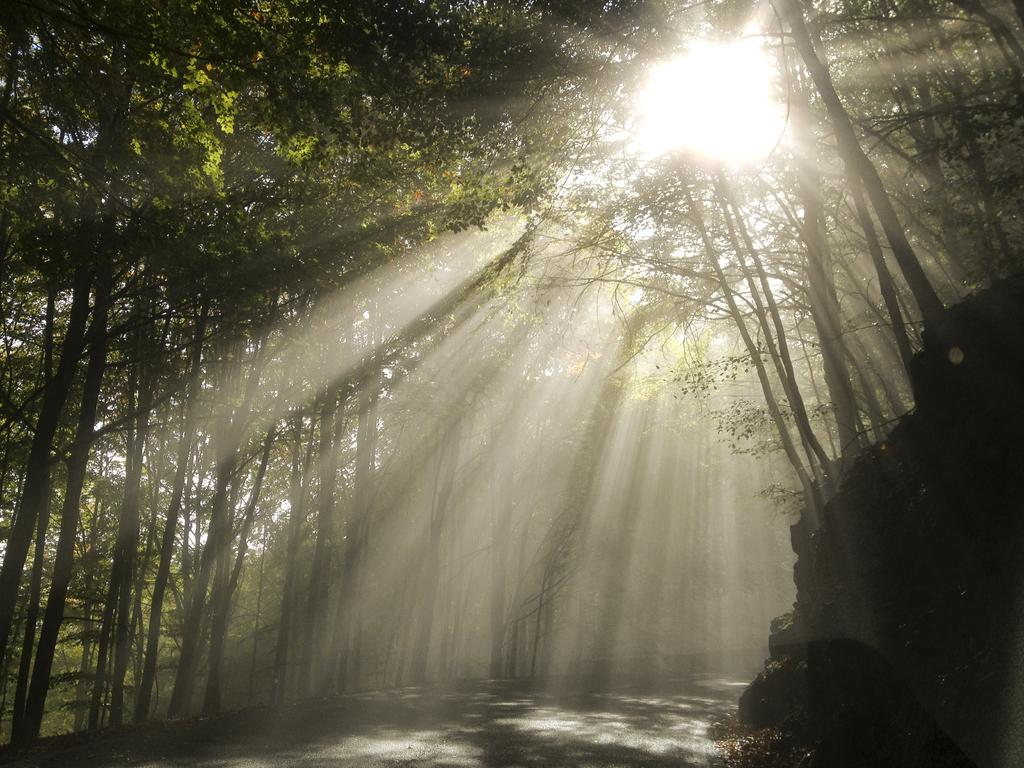What is the main feature in the center of the image? There is a road in the center of the image. What can be found on the left side of the image? There are rocks on the left side of the image. What type of vegetation is present in the image? There are trees in the image. What is visible in the background of the image? The sun is visible in the background of the image. How many pies are sitting on the rocks in the image? There are no pies present in the image; it features a road, rocks, trees, and the sun. What type of metal can be seen in the image? There is no metal visible in the image. 